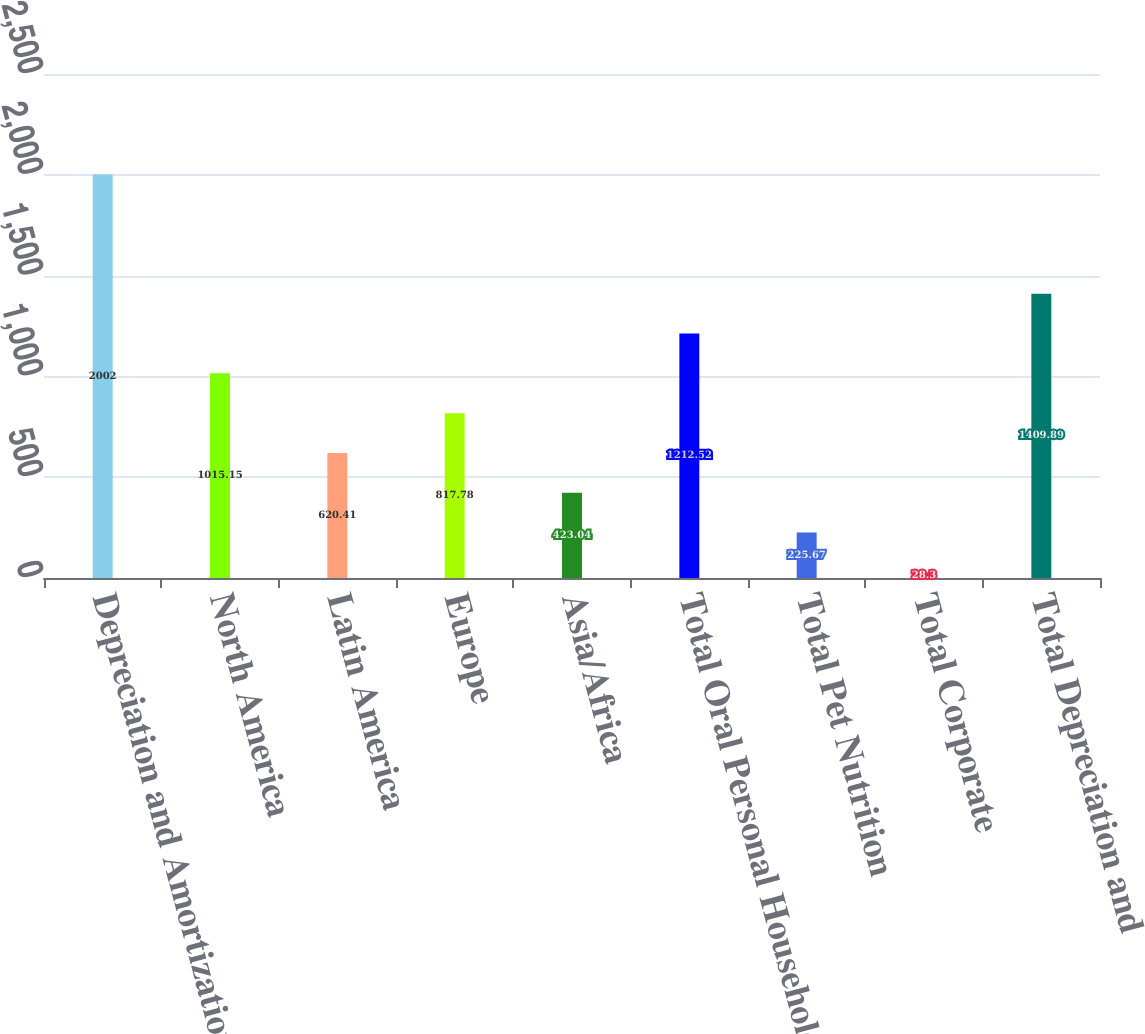Convert chart. <chart><loc_0><loc_0><loc_500><loc_500><bar_chart><fcel>Depreciation and Amortization<fcel>North America<fcel>Latin America<fcel>Europe<fcel>Asia/Africa<fcel>Total Oral Personal Household<fcel>Total Pet Nutrition<fcel>Total Corporate<fcel>Total Depreciation and<nl><fcel>2002<fcel>1015.15<fcel>620.41<fcel>817.78<fcel>423.04<fcel>1212.52<fcel>225.67<fcel>28.3<fcel>1409.89<nl></chart> 